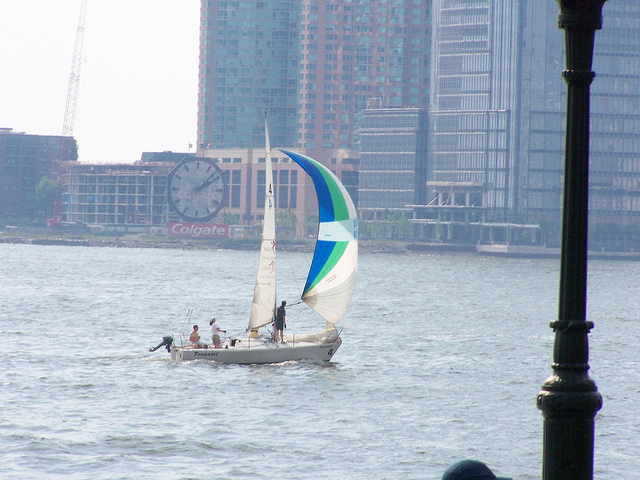Describe the weather conditions evident in this image. The weather in the image appears to be fair, with sufficient wind to fill the sails of the sailboat, suggesting a breezy day. The visibility is good, indicating no fog or heavy precipitation, and the sky is mostly clear with only a few wisps of clouds, which would be consistent with a pleasant, dry day, likely comfortable for outdoor activities like sailing. 